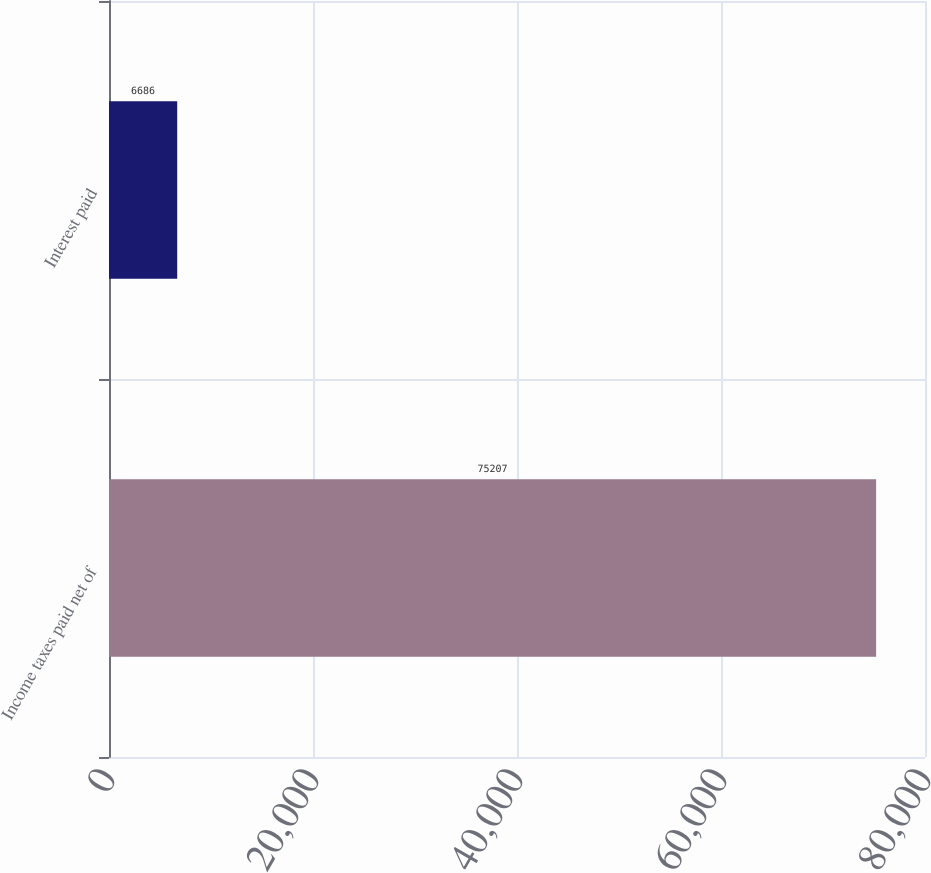<chart> <loc_0><loc_0><loc_500><loc_500><bar_chart><fcel>Income taxes paid net of<fcel>Interest paid<nl><fcel>75207<fcel>6686<nl></chart> 